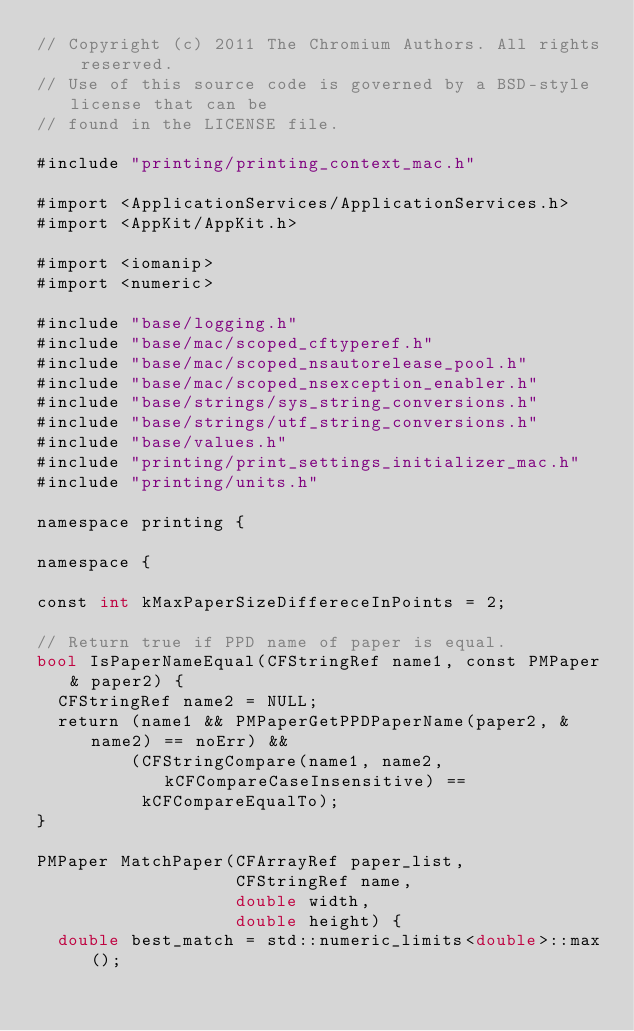<code> <loc_0><loc_0><loc_500><loc_500><_ObjectiveC_>// Copyright (c) 2011 The Chromium Authors. All rights reserved.
// Use of this source code is governed by a BSD-style license that can be
// found in the LICENSE file.

#include "printing/printing_context_mac.h"

#import <ApplicationServices/ApplicationServices.h>
#import <AppKit/AppKit.h>

#import <iomanip>
#import <numeric>

#include "base/logging.h"
#include "base/mac/scoped_cftyperef.h"
#include "base/mac/scoped_nsautorelease_pool.h"
#include "base/mac/scoped_nsexception_enabler.h"
#include "base/strings/sys_string_conversions.h"
#include "base/strings/utf_string_conversions.h"
#include "base/values.h"
#include "printing/print_settings_initializer_mac.h"
#include "printing/units.h"

namespace printing {

namespace {

const int kMaxPaperSizeDiffereceInPoints = 2;

// Return true if PPD name of paper is equal.
bool IsPaperNameEqual(CFStringRef name1, const PMPaper& paper2) {
  CFStringRef name2 = NULL;
  return (name1 && PMPaperGetPPDPaperName(paper2, &name2) == noErr) &&
         (CFStringCompare(name1, name2, kCFCompareCaseInsensitive) ==
          kCFCompareEqualTo);
}

PMPaper MatchPaper(CFArrayRef paper_list,
                   CFStringRef name,
                   double width,
                   double height) {
  double best_match = std::numeric_limits<double>::max();</code> 